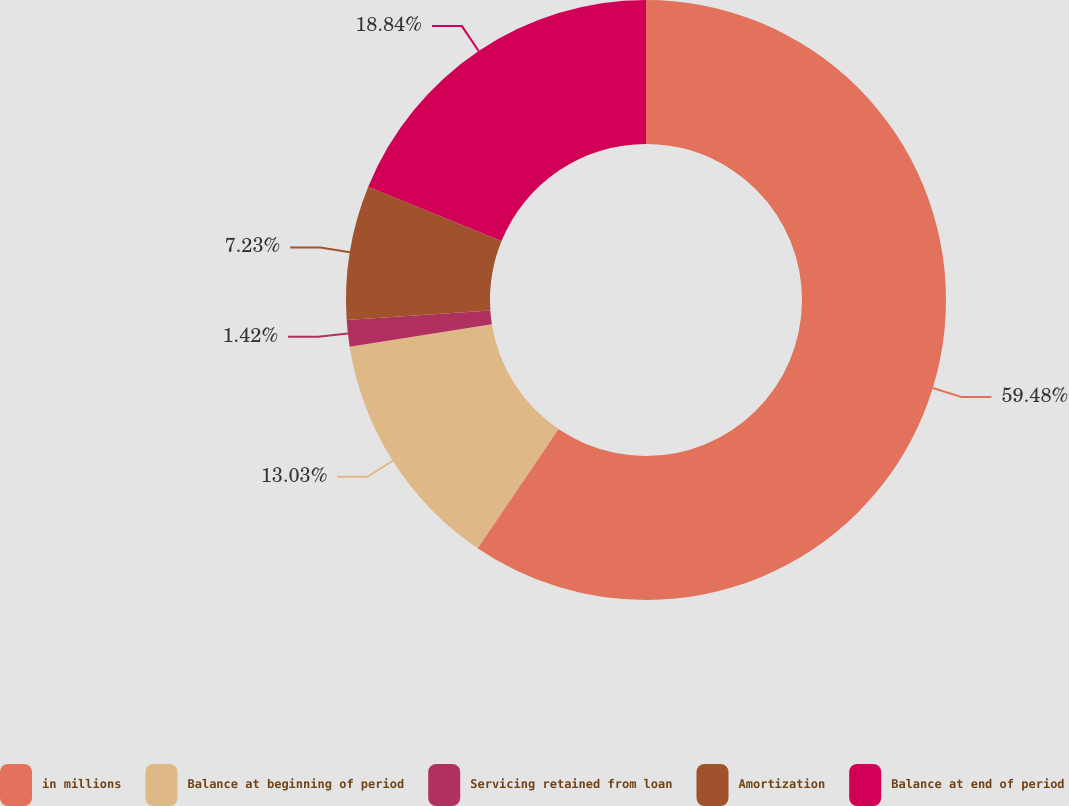Convert chart. <chart><loc_0><loc_0><loc_500><loc_500><pie_chart><fcel>in millions<fcel>Balance at beginning of period<fcel>Servicing retained from loan<fcel>Amortization<fcel>Balance at end of period<nl><fcel>59.49%<fcel>13.03%<fcel>1.42%<fcel>7.23%<fcel>18.84%<nl></chart> 